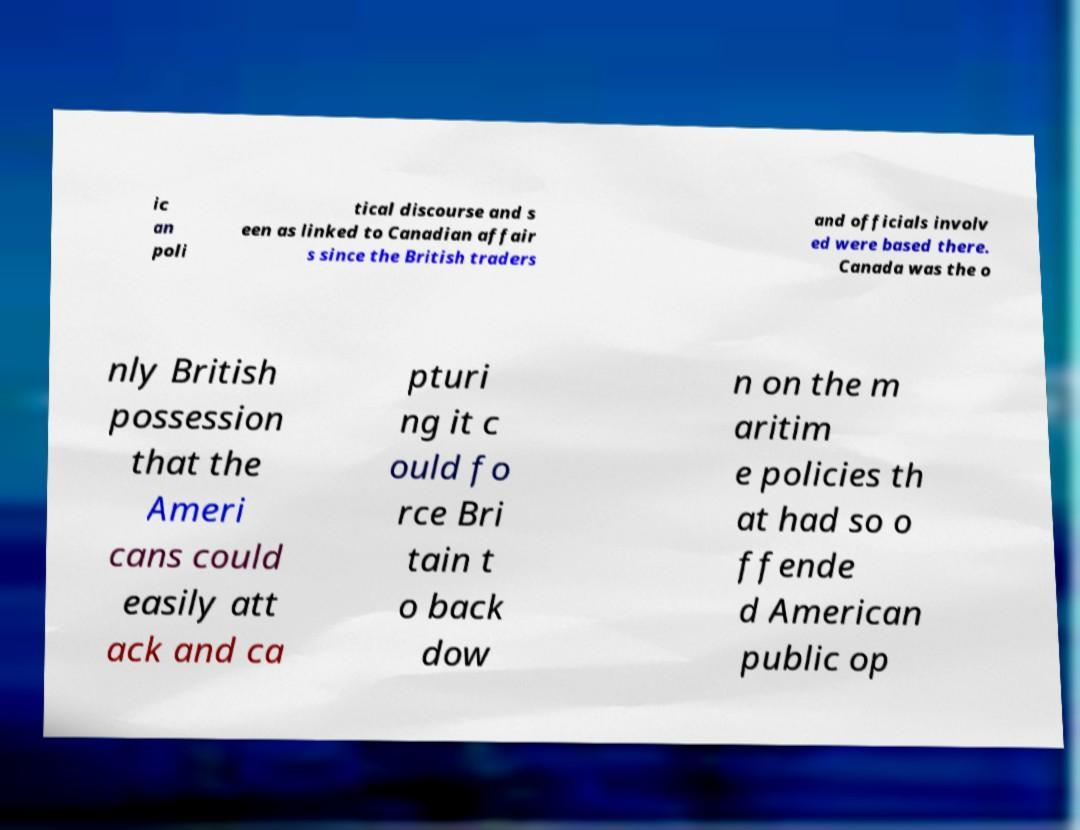Could you assist in decoding the text presented in this image and type it out clearly? ic an poli tical discourse and s een as linked to Canadian affair s since the British traders and officials involv ed were based there. Canada was the o nly British possession that the Ameri cans could easily att ack and ca pturi ng it c ould fo rce Bri tain t o back dow n on the m aritim e policies th at had so o ffende d American public op 